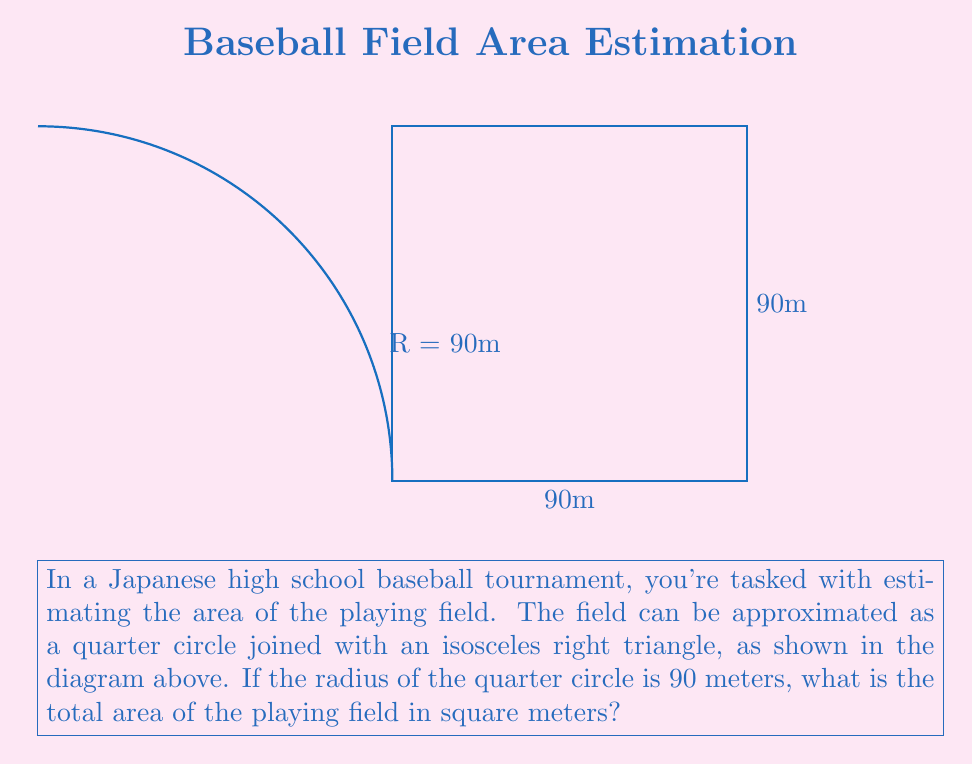Give your solution to this math problem. Let's break this down step-by-step:

1) The field is composed of two parts: a quarter circle and an isosceles right triangle.

2) For the quarter circle:
   - Area of a full circle is $A = \pi r^2$
   - Area of a quarter circle is $A_{quarter} = \frac{1}{4} \pi r^2$
   - With $r = 90$ m, $A_{quarter} = \frac{1}{4} \pi (90)^2 = 6358.5$ m²

3) For the isosceles right triangle:
   - Both sides of the triangle are 90 m
   - Area of a triangle is $A = \frac{1}{2} \text{base} \times \text{height}$
   - $A_{triangle} = \frac{1}{2} \times 90 \times 90 = 4050$ m²

4) Total area:
   $A_{total} = A_{quarter} + A_{triangle}$
   $A_{total} = 6358.5 + 4050 = 10408.5$ m²

5) Rounding to the nearest whole number: 10409 m²
Answer: 10409 m² 